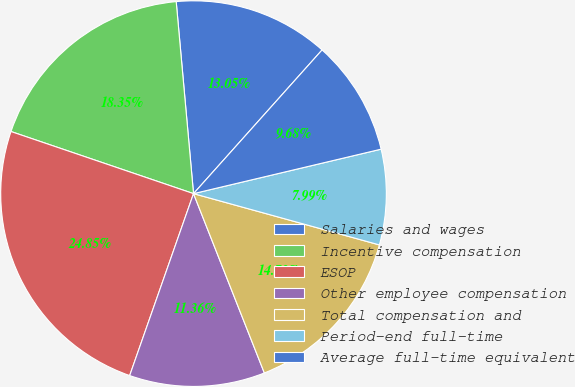<chart> <loc_0><loc_0><loc_500><loc_500><pie_chart><fcel>Salaries and wages<fcel>Incentive compensation<fcel>ESOP<fcel>Other employee compensation<fcel>Total compensation and<fcel>Period-end full-time<fcel>Average full-time equivalent<nl><fcel>13.05%<fcel>18.35%<fcel>24.85%<fcel>11.36%<fcel>14.73%<fcel>7.99%<fcel>9.68%<nl></chart> 